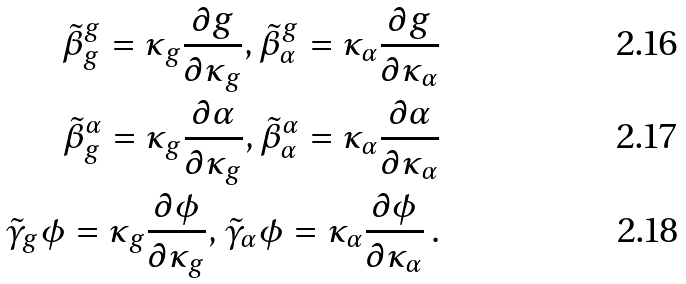<formula> <loc_0><loc_0><loc_500><loc_500>\tilde { \beta } ^ { g } _ { g } = \kappa _ { g } \frac { \partial g } { \partial \kappa _ { g } } , \tilde { \beta } ^ { g } _ { \alpha } = \kappa _ { \alpha } \frac { \partial g } { \partial \kappa _ { \alpha } } \\ \tilde { \beta } ^ { \alpha } _ { g } = \kappa _ { g } \frac { \partial \alpha } { \partial \kappa _ { g } } , \tilde { \beta } ^ { \alpha } _ { \alpha } = \kappa _ { \alpha } \frac { \partial \alpha } { \partial \kappa _ { \alpha } } \\ \tilde { \gamma } _ { g } \phi = \kappa _ { g } \frac { \partial \phi } { \partial \kappa _ { g } } , \tilde { \gamma } _ { \alpha } \phi = \kappa _ { \alpha } \frac { \partial \phi } { \partial \kappa _ { \alpha } } \, .</formula> 